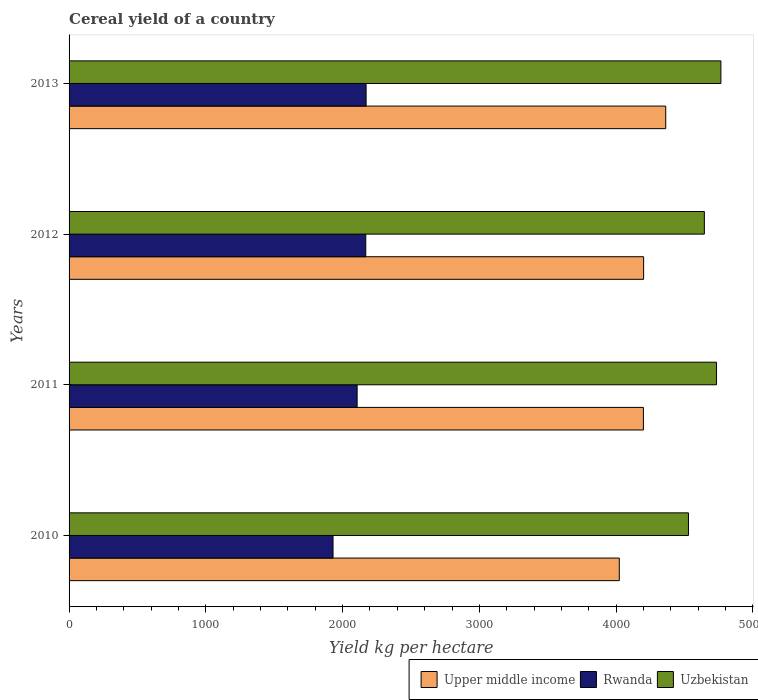Are the number of bars on each tick of the Y-axis equal?
Your answer should be compact. Yes. How many bars are there on the 3rd tick from the bottom?
Your answer should be very brief. 3. What is the label of the 2nd group of bars from the top?
Provide a succinct answer. 2012. What is the total cereal yield in Rwanda in 2013?
Give a very brief answer. 2171.82. Across all years, what is the maximum total cereal yield in Uzbekistan?
Provide a succinct answer. 4766.26. Across all years, what is the minimum total cereal yield in Rwanda?
Your answer should be compact. 1930.06. What is the total total cereal yield in Upper middle income in the graph?
Your answer should be very brief. 1.68e+04. What is the difference between the total cereal yield in Uzbekistan in 2011 and that in 2013?
Your answer should be compact. -31.98. What is the difference between the total cereal yield in Rwanda in 2010 and the total cereal yield in Uzbekistan in 2013?
Your response must be concise. -2836.2. What is the average total cereal yield in Rwanda per year?
Your response must be concise. 2094.4. In the year 2010, what is the difference between the total cereal yield in Upper middle income and total cereal yield in Uzbekistan?
Offer a very short reply. -505.78. In how many years, is the total cereal yield in Upper middle income greater than 2000 kg per hectare?
Make the answer very short. 4. What is the ratio of the total cereal yield in Uzbekistan in 2011 to that in 2013?
Give a very brief answer. 0.99. Is the difference between the total cereal yield in Upper middle income in 2010 and 2012 greater than the difference between the total cereal yield in Uzbekistan in 2010 and 2012?
Your answer should be compact. No. What is the difference between the highest and the second highest total cereal yield in Rwanda?
Offer a terse response. 2.32. What is the difference between the highest and the lowest total cereal yield in Rwanda?
Your answer should be very brief. 241.77. Is the sum of the total cereal yield in Upper middle income in 2012 and 2013 greater than the maximum total cereal yield in Uzbekistan across all years?
Your response must be concise. Yes. What does the 1st bar from the top in 2012 represents?
Provide a succinct answer. Uzbekistan. What does the 2nd bar from the bottom in 2011 represents?
Keep it short and to the point. Rwanda. Is it the case that in every year, the sum of the total cereal yield in Rwanda and total cereal yield in Upper middle income is greater than the total cereal yield in Uzbekistan?
Ensure brevity in your answer.  Yes. How many bars are there?
Your answer should be very brief. 12. How many years are there in the graph?
Your response must be concise. 4. Are the values on the major ticks of X-axis written in scientific E-notation?
Provide a short and direct response. No. Where does the legend appear in the graph?
Offer a terse response. Bottom right. How many legend labels are there?
Ensure brevity in your answer.  3. How are the legend labels stacked?
Provide a short and direct response. Horizontal. What is the title of the graph?
Provide a short and direct response. Cereal yield of a country. What is the label or title of the X-axis?
Keep it short and to the point. Yield kg per hectare. What is the Yield kg per hectare of Upper middle income in 2010?
Keep it short and to the point. 4023.3. What is the Yield kg per hectare in Rwanda in 2010?
Your answer should be compact. 1930.06. What is the Yield kg per hectare in Uzbekistan in 2010?
Your answer should be compact. 4529.08. What is the Yield kg per hectare of Upper middle income in 2011?
Offer a very short reply. 4199.62. What is the Yield kg per hectare in Rwanda in 2011?
Offer a very short reply. 2106.23. What is the Yield kg per hectare of Uzbekistan in 2011?
Your answer should be very brief. 4734.27. What is the Yield kg per hectare in Upper middle income in 2012?
Give a very brief answer. 4201.25. What is the Yield kg per hectare in Rwanda in 2012?
Ensure brevity in your answer.  2169.5. What is the Yield kg per hectare of Uzbekistan in 2012?
Offer a very short reply. 4645.26. What is the Yield kg per hectare in Upper middle income in 2013?
Keep it short and to the point. 4362.86. What is the Yield kg per hectare in Rwanda in 2013?
Offer a terse response. 2171.82. What is the Yield kg per hectare in Uzbekistan in 2013?
Provide a short and direct response. 4766.26. Across all years, what is the maximum Yield kg per hectare of Upper middle income?
Your answer should be compact. 4362.86. Across all years, what is the maximum Yield kg per hectare of Rwanda?
Your response must be concise. 2171.82. Across all years, what is the maximum Yield kg per hectare in Uzbekistan?
Give a very brief answer. 4766.26. Across all years, what is the minimum Yield kg per hectare of Upper middle income?
Provide a succinct answer. 4023.3. Across all years, what is the minimum Yield kg per hectare in Rwanda?
Keep it short and to the point. 1930.06. Across all years, what is the minimum Yield kg per hectare in Uzbekistan?
Provide a succinct answer. 4529.08. What is the total Yield kg per hectare in Upper middle income in the graph?
Provide a short and direct response. 1.68e+04. What is the total Yield kg per hectare of Rwanda in the graph?
Provide a short and direct response. 8377.6. What is the total Yield kg per hectare of Uzbekistan in the graph?
Offer a terse response. 1.87e+04. What is the difference between the Yield kg per hectare of Upper middle income in 2010 and that in 2011?
Ensure brevity in your answer.  -176.32. What is the difference between the Yield kg per hectare in Rwanda in 2010 and that in 2011?
Give a very brief answer. -176.17. What is the difference between the Yield kg per hectare in Uzbekistan in 2010 and that in 2011?
Ensure brevity in your answer.  -205.2. What is the difference between the Yield kg per hectare of Upper middle income in 2010 and that in 2012?
Provide a succinct answer. -177.95. What is the difference between the Yield kg per hectare of Rwanda in 2010 and that in 2012?
Offer a terse response. -239.44. What is the difference between the Yield kg per hectare in Uzbekistan in 2010 and that in 2012?
Your response must be concise. -116.19. What is the difference between the Yield kg per hectare in Upper middle income in 2010 and that in 2013?
Give a very brief answer. -339.56. What is the difference between the Yield kg per hectare of Rwanda in 2010 and that in 2013?
Keep it short and to the point. -241.76. What is the difference between the Yield kg per hectare in Uzbekistan in 2010 and that in 2013?
Offer a terse response. -237.18. What is the difference between the Yield kg per hectare in Upper middle income in 2011 and that in 2012?
Provide a succinct answer. -1.63. What is the difference between the Yield kg per hectare in Rwanda in 2011 and that in 2012?
Your answer should be compact. -63.27. What is the difference between the Yield kg per hectare in Uzbekistan in 2011 and that in 2012?
Provide a short and direct response. 89.01. What is the difference between the Yield kg per hectare of Upper middle income in 2011 and that in 2013?
Give a very brief answer. -163.24. What is the difference between the Yield kg per hectare of Rwanda in 2011 and that in 2013?
Make the answer very short. -65.59. What is the difference between the Yield kg per hectare in Uzbekistan in 2011 and that in 2013?
Keep it short and to the point. -31.98. What is the difference between the Yield kg per hectare of Upper middle income in 2012 and that in 2013?
Give a very brief answer. -161.61. What is the difference between the Yield kg per hectare in Rwanda in 2012 and that in 2013?
Your response must be concise. -2.32. What is the difference between the Yield kg per hectare in Uzbekistan in 2012 and that in 2013?
Your response must be concise. -120.99. What is the difference between the Yield kg per hectare of Upper middle income in 2010 and the Yield kg per hectare of Rwanda in 2011?
Make the answer very short. 1917.07. What is the difference between the Yield kg per hectare of Upper middle income in 2010 and the Yield kg per hectare of Uzbekistan in 2011?
Your answer should be compact. -710.98. What is the difference between the Yield kg per hectare in Rwanda in 2010 and the Yield kg per hectare in Uzbekistan in 2011?
Offer a very short reply. -2804.22. What is the difference between the Yield kg per hectare of Upper middle income in 2010 and the Yield kg per hectare of Rwanda in 2012?
Your answer should be very brief. 1853.8. What is the difference between the Yield kg per hectare in Upper middle income in 2010 and the Yield kg per hectare in Uzbekistan in 2012?
Keep it short and to the point. -621.96. What is the difference between the Yield kg per hectare of Rwanda in 2010 and the Yield kg per hectare of Uzbekistan in 2012?
Keep it short and to the point. -2715.21. What is the difference between the Yield kg per hectare of Upper middle income in 2010 and the Yield kg per hectare of Rwanda in 2013?
Keep it short and to the point. 1851.48. What is the difference between the Yield kg per hectare of Upper middle income in 2010 and the Yield kg per hectare of Uzbekistan in 2013?
Keep it short and to the point. -742.96. What is the difference between the Yield kg per hectare of Rwanda in 2010 and the Yield kg per hectare of Uzbekistan in 2013?
Provide a short and direct response. -2836.2. What is the difference between the Yield kg per hectare in Upper middle income in 2011 and the Yield kg per hectare in Rwanda in 2012?
Give a very brief answer. 2030.12. What is the difference between the Yield kg per hectare in Upper middle income in 2011 and the Yield kg per hectare in Uzbekistan in 2012?
Your answer should be very brief. -445.64. What is the difference between the Yield kg per hectare in Rwanda in 2011 and the Yield kg per hectare in Uzbekistan in 2012?
Make the answer very short. -2539.03. What is the difference between the Yield kg per hectare of Upper middle income in 2011 and the Yield kg per hectare of Rwanda in 2013?
Offer a terse response. 2027.8. What is the difference between the Yield kg per hectare in Upper middle income in 2011 and the Yield kg per hectare in Uzbekistan in 2013?
Your answer should be very brief. -566.63. What is the difference between the Yield kg per hectare of Rwanda in 2011 and the Yield kg per hectare of Uzbekistan in 2013?
Provide a short and direct response. -2660.03. What is the difference between the Yield kg per hectare in Upper middle income in 2012 and the Yield kg per hectare in Rwanda in 2013?
Give a very brief answer. 2029.43. What is the difference between the Yield kg per hectare in Upper middle income in 2012 and the Yield kg per hectare in Uzbekistan in 2013?
Provide a succinct answer. -565.01. What is the difference between the Yield kg per hectare of Rwanda in 2012 and the Yield kg per hectare of Uzbekistan in 2013?
Provide a succinct answer. -2596.76. What is the average Yield kg per hectare in Upper middle income per year?
Offer a very short reply. 4196.76. What is the average Yield kg per hectare in Rwanda per year?
Offer a very short reply. 2094.4. What is the average Yield kg per hectare in Uzbekistan per year?
Provide a succinct answer. 4668.72. In the year 2010, what is the difference between the Yield kg per hectare in Upper middle income and Yield kg per hectare in Rwanda?
Give a very brief answer. 2093.24. In the year 2010, what is the difference between the Yield kg per hectare of Upper middle income and Yield kg per hectare of Uzbekistan?
Provide a succinct answer. -505.78. In the year 2010, what is the difference between the Yield kg per hectare in Rwanda and Yield kg per hectare in Uzbekistan?
Make the answer very short. -2599.02. In the year 2011, what is the difference between the Yield kg per hectare of Upper middle income and Yield kg per hectare of Rwanda?
Your response must be concise. 2093.39. In the year 2011, what is the difference between the Yield kg per hectare in Upper middle income and Yield kg per hectare in Uzbekistan?
Offer a terse response. -534.65. In the year 2011, what is the difference between the Yield kg per hectare in Rwanda and Yield kg per hectare in Uzbekistan?
Offer a terse response. -2628.05. In the year 2012, what is the difference between the Yield kg per hectare of Upper middle income and Yield kg per hectare of Rwanda?
Ensure brevity in your answer.  2031.75. In the year 2012, what is the difference between the Yield kg per hectare in Upper middle income and Yield kg per hectare in Uzbekistan?
Make the answer very short. -444.01. In the year 2012, what is the difference between the Yield kg per hectare in Rwanda and Yield kg per hectare in Uzbekistan?
Provide a short and direct response. -2475.76. In the year 2013, what is the difference between the Yield kg per hectare in Upper middle income and Yield kg per hectare in Rwanda?
Give a very brief answer. 2191.04. In the year 2013, what is the difference between the Yield kg per hectare in Upper middle income and Yield kg per hectare in Uzbekistan?
Your answer should be very brief. -403.39. In the year 2013, what is the difference between the Yield kg per hectare in Rwanda and Yield kg per hectare in Uzbekistan?
Keep it short and to the point. -2594.43. What is the ratio of the Yield kg per hectare of Upper middle income in 2010 to that in 2011?
Provide a short and direct response. 0.96. What is the ratio of the Yield kg per hectare in Rwanda in 2010 to that in 2011?
Offer a very short reply. 0.92. What is the ratio of the Yield kg per hectare of Uzbekistan in 2010 to that in 2011?
Your answer should be very brief. 0.96. What is the ratio of the Yield kg per hectare in Upper middle income in 2010 to that in 2012?
Provide a short and direct response. 0.96. What is the ratio of the Yield kg per hectare of Rwanda in 2010 to that in 2012?
Offer a terse response. 0.89. What is the ratio of the Yield kg per hectare in Upper middle income in 2010 to that in 2013?
Make the answer very short. 0.92. What is the ratio of the Yield kg per hectare of Rwanda in 2010 to that in 2013?
Your answer should be compact. 0.89. What is the ratio of the Yield kg per hectare of Uzbekistan in 2010 to that in 2013?
Make the answer very short. 0.95. What is the ratio of the Yield kg per hectare of Upper middle income in 2011 to that in 2012?
Ensure brevity in your answer.  1. What is the ratio of the Yield kg per hectare of Rwanda in 2011 to that in 2012?
Provide a short and direct response. 0.97. What is the ratio of the Yield kg per hectare of Uzbekistan in 2011 to that in 2012?
Your answer should be compact. 1.02. What is the ratio of the Yield kg per hectare of Upper middle income in 2011 to that in 2013?
Ensure brevity in your answer.  0.96. What is the ratio of the Yield kg per hectare in Rwanda in 2011 to that in 2013?
Ensure brevity in your answer.  0.97. What is the ratio of the Yield kg per hectare of Upper middle income in 2012 to that in 2013?
Keep it short and to the point. 0.96. What is the ratio of the Yield kg per hectare in Rwanda in 2012 to that in 2013?
Your answer should be compact. 1. What is the ratio of the Yield kg per hectare in Uzbekistan in 2012 to that in 2013?
Offer a terse response. 0.97. What is the difference between the highest and the second highest Yield kg per hectare in Upper middle income?
Provide a succinct answer. 161.61. What is the difference between the highest and the second highest Yield kg per hectare in Rwanda?
Give a very brief answer. 2.32. What is the difference between the highest and the second highest Yield kg per hectare in Uzbekistan?
Your response must be concise. 31.98. What is the difference between the highest and the lowest Yield kg per hectare in Upper middle income?
Keep it short and to the point. 339.56. What is the difference between the highest and the lowest Yield kg per hectare of Rwanda?
Make the answer very short. 241.76. What is the difference between the highest and the lowest Yield kg per hectare of Uzbekistan?
Your response must be concise. 237.18. 